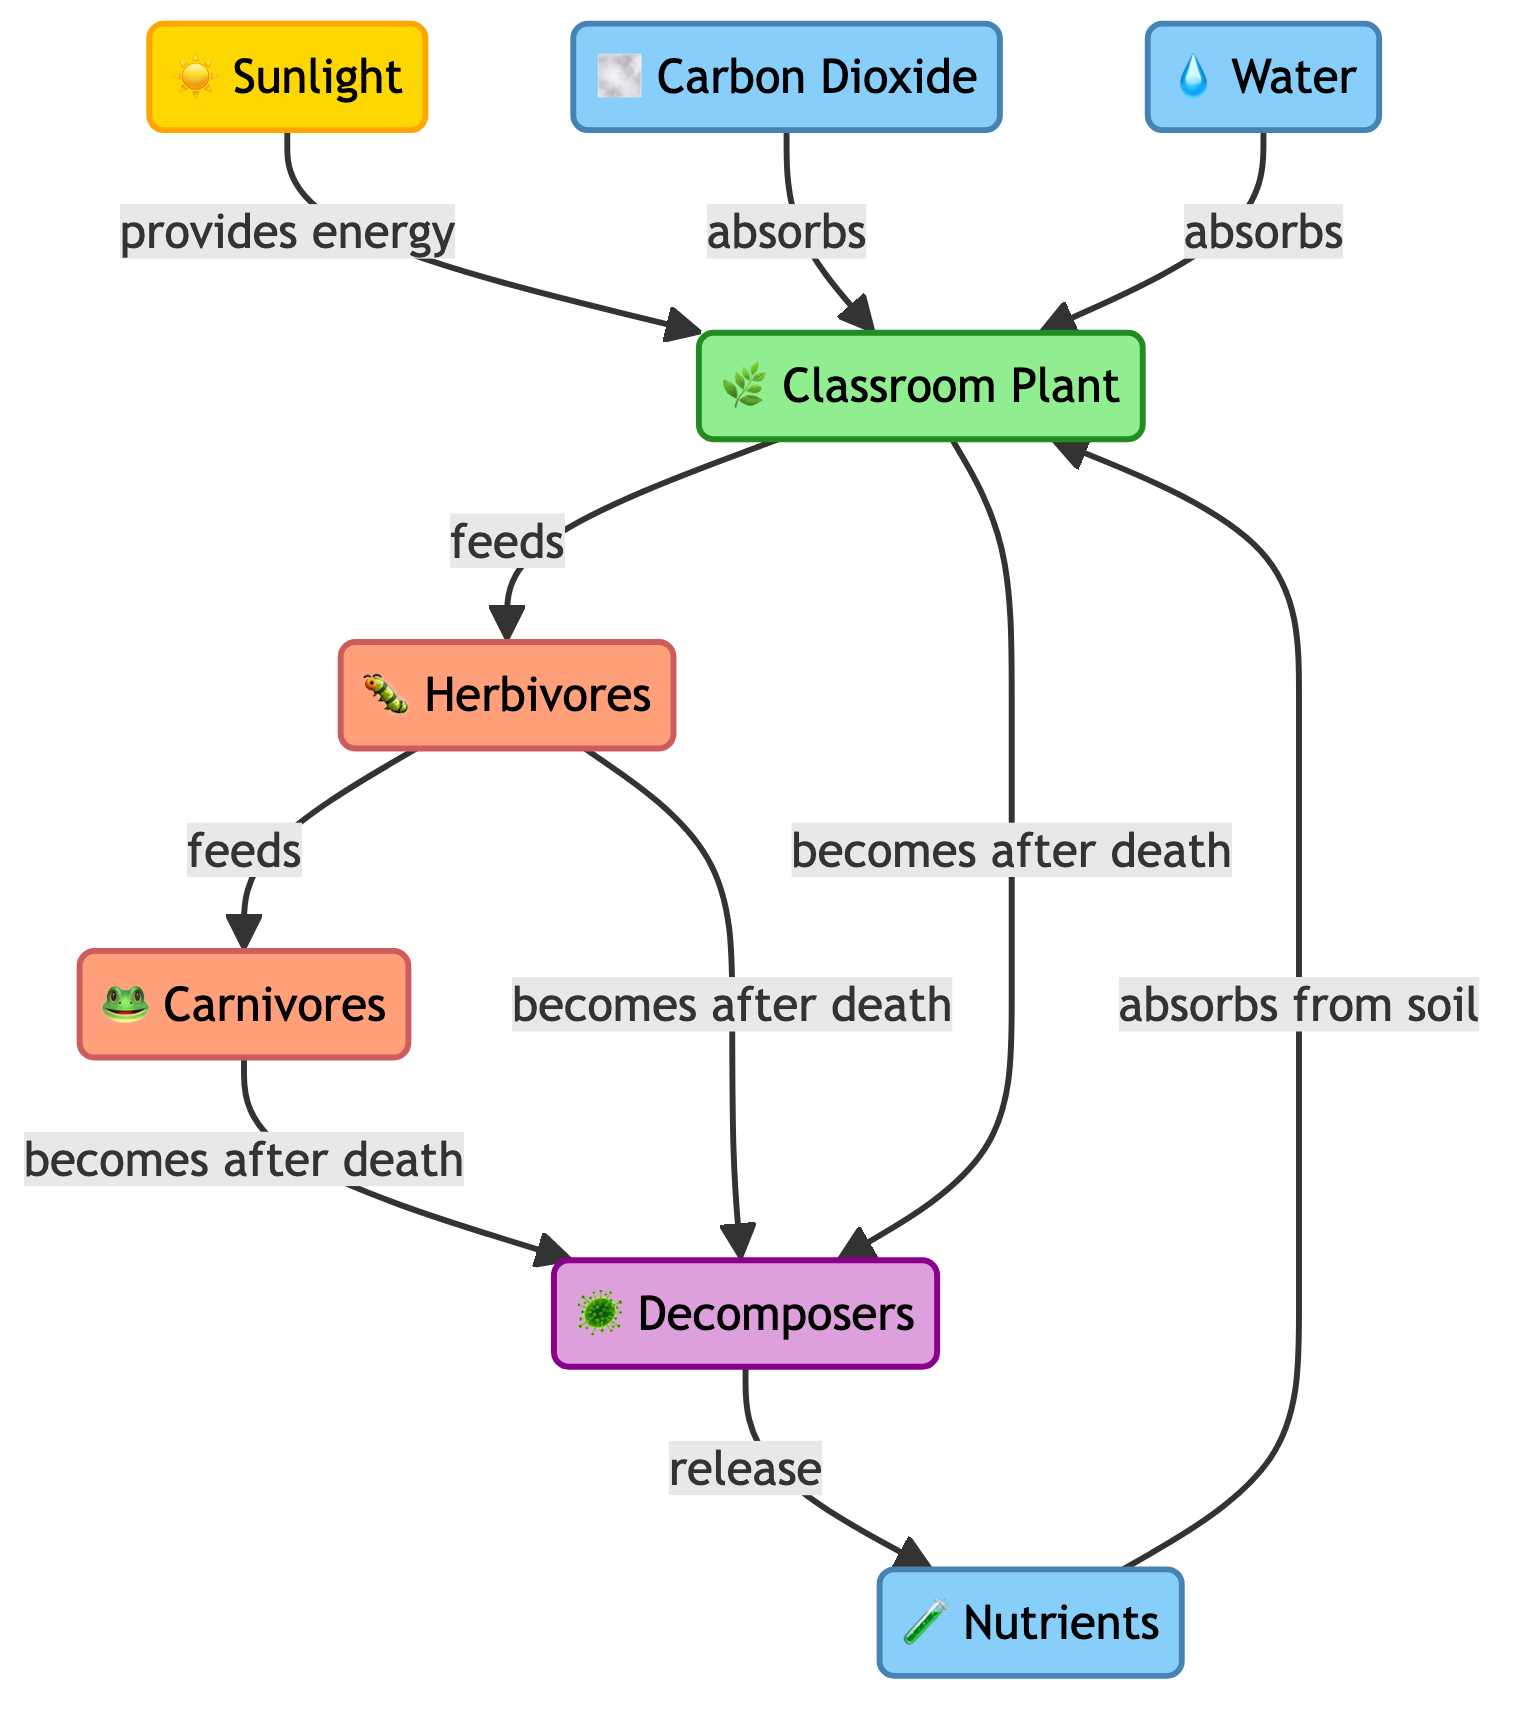What provides energy to the classroom plant? The diagram indicates that sunlight provides energy to the classroom plant, as shown by the arrow labeled "provides energy" pointing from sunlight to plant.
Answer: Sunlight How many resources are absorbed by the classroom plant? The diagram shows that the classroom plant absorbs three resources: carbon dioxide, water, and nutrients. By counting the arrows leading into the plant labeled "absorbs," we find three distinct sources.
Answer: Three Who feeds on the classroom plant? According to the diagram, herbivores feed on the classroom plant, which is indicated by the arrow labeled "feeds" pointing from plant to herbivores.
Answer: Herbivores What role do decomposers play in the food chain? The diagram illustrates that decomposers decompose the remains of plants, herbivores, and carnivores and release nutrients back into the soil. This is seen in the arrows leading from each of these organisms to decomposers and the subsequent release of nutrients.
Answer: Nutrient release How does the nutrient flow get replenished in the classroom plant system? The diagram shows that nutrients are released by decomposers, which occurs after the decomposition of plants, herbivores, and carnivores. Therefore, the nutrient flow is replenished when decomposers break down organic matter and release nutrients into the soil.
Answer: Through decomposers What do carnivores consume? From the diagram, it is clear that carnivores feed on herbivores, as indicated by the arrow labeled "feeds" pointing from herbivores to carnivores.
Answer: Herbivores How many consumers are present in the food chain? The diagram shows two types of consumers: herbivores and carnivores. By counting both, we can determine the total number of consumer types present.
Answer: Two Which resource is not absorbed by the classroom plant? The diagram lists sunlight, carbon dioxide, water, and nutrients as resources absorbed by the classroom plant, indicating that none of these options are excluded, while the specific resources not absorbed are not mentioned. Without additional context given, however, we can infer there could be others not listed.
Answer: N/A 